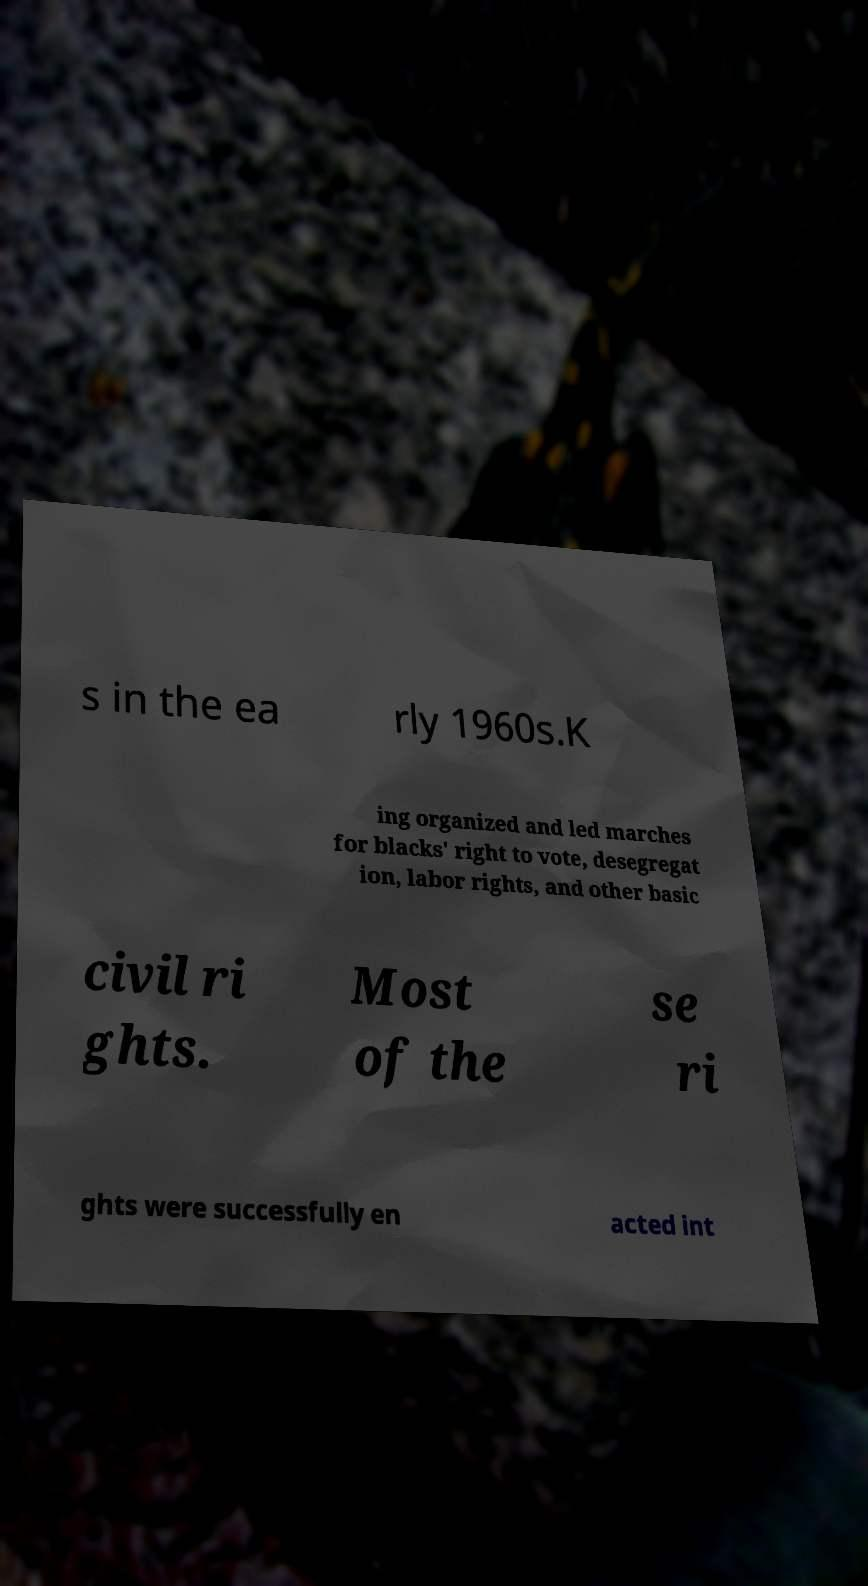For documentation purposes, I need the text within this image transcribed. Could you provide that? s in the ea rly 1960s.K ing organized and led marches for blacks' right to vote, desegregat ion, labor rights, and other basic civil ri ghts. Most of the se ri ghts were successfully en acted int 